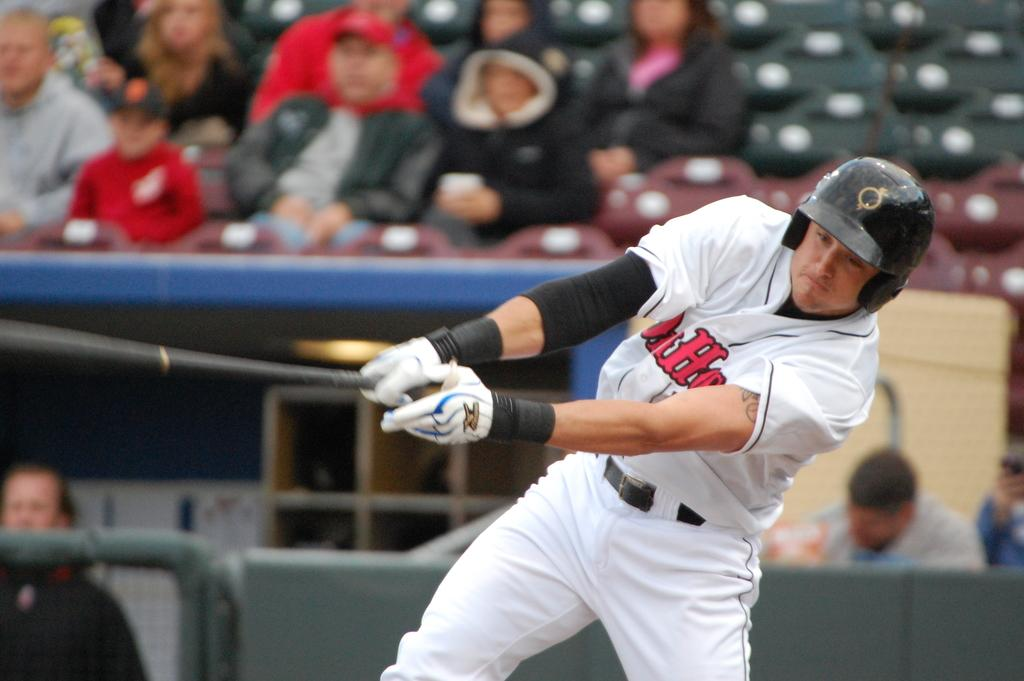<image>
Render a clear and concise summary of the photo. a man with the letter H on his jersey playing 